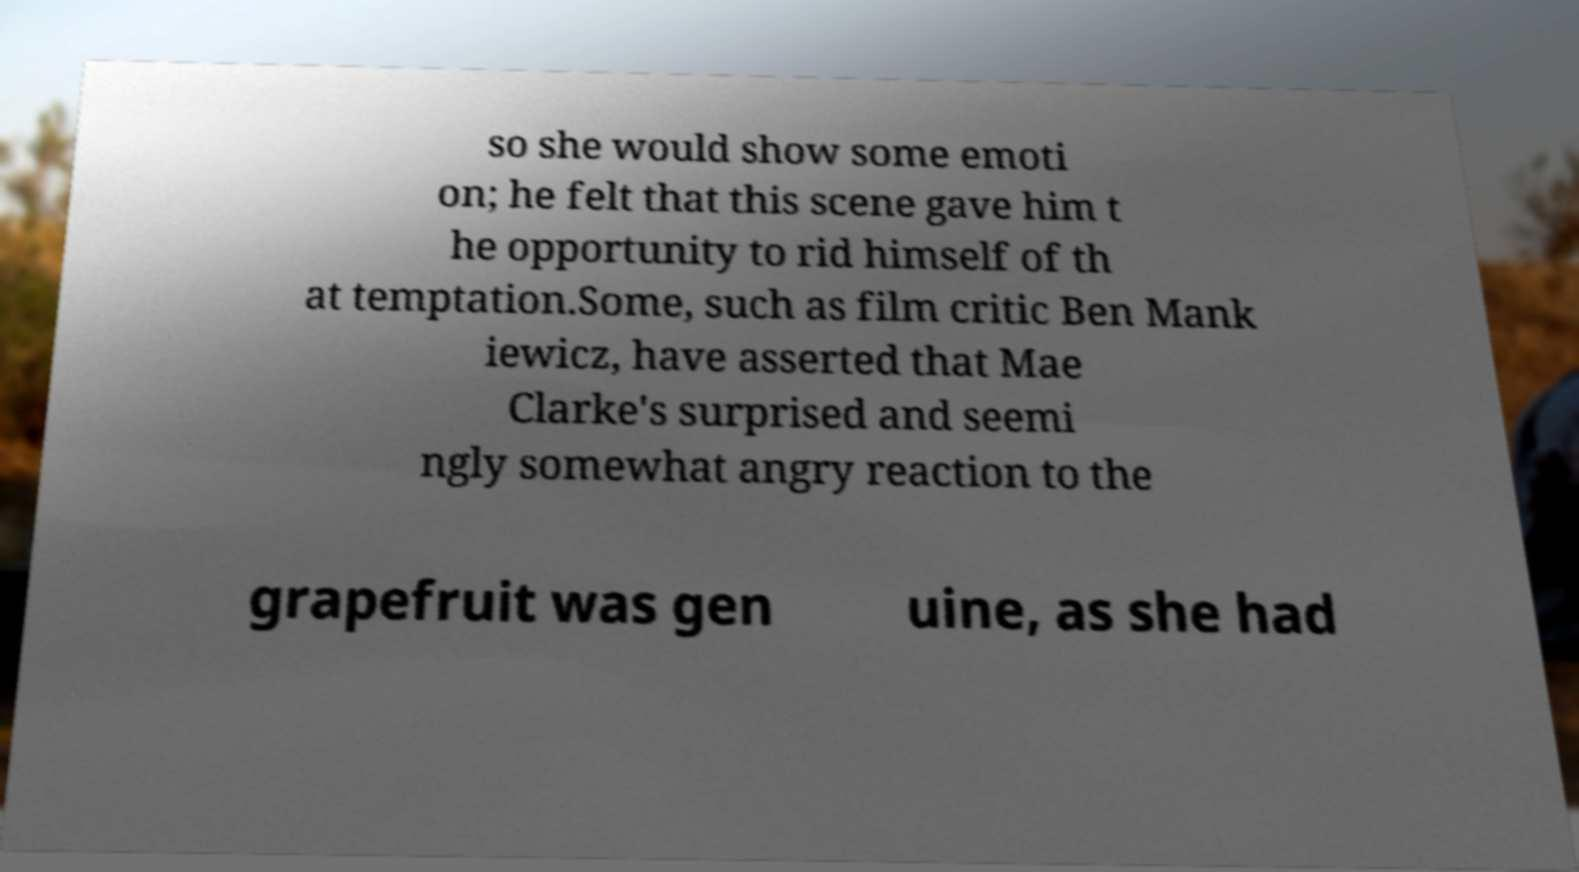Please read and relay the text visible in this image. What does it say? so she would show some emoti on; he felt that this scene gave him t he opportunity to rid himself of th at temptation.Some, such as film critic Ben Mank iewicz, have asserted that Mae Clarke's surprised and seemi ngly somewhat angry reaction to the grapefruit was gen uine, as she had 